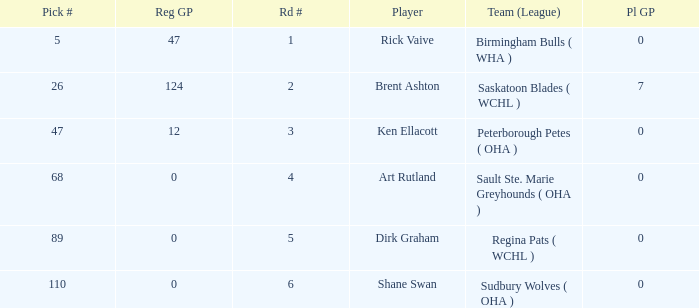How many reg GP for rick vaive in round 1? None. 